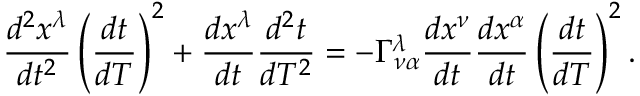<formula> <loc_0><loc_0><loc_500><loc_500>{ \frac { d ^ { 2 } x ^ { \lambda } } { d t ^ { 2 } } } \left ( { \frac { d t } { d T } } \right ) ^ { 2 } + { \frac { d x ^ { \lambda } } { d t } } { \frac { d ^ { 2 } t } { d T ^ { 2 } } } = - \Gamma _ { \nu \alpha } ^ { \lambda } { \frac { d x ^ { \nu } } { d t } } { \frac { d x ^ { \alpha } } { d t } } \left ( { \frac { d t } { d T } } \right ) ^ { 2 } .</formula> 